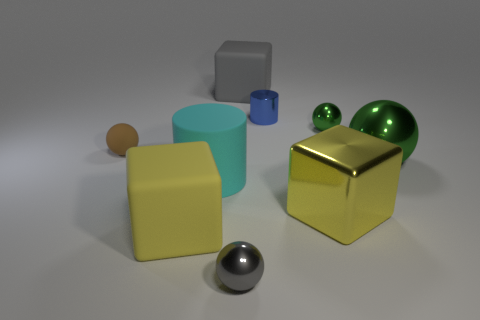Subtract all yellow cubes. How many cubes are left? 1 Subtract all gray spheres. How many spheres are left? 3 Subtract 2 cylinders. How many cylinders are left? 0 Subtract all balls. How many objects are left? 5 Subtract all blue cubes. How many purple cylinders are left? 0 Subtract all tiny brown balls. Subtract all blue objects. How many objects are left? 7 Add 9 large cyan rubber cylinders. How many large cyan rubber cylinders are left? 10 Add 3 large cyan matte cylinders. How many large cyan matte cylinders exist? 4 Subtract 0 gray cylinders. How many objects are left? 9 Subtract all brown blocks. Subtract all blue balls. How many blocks are left? 3 